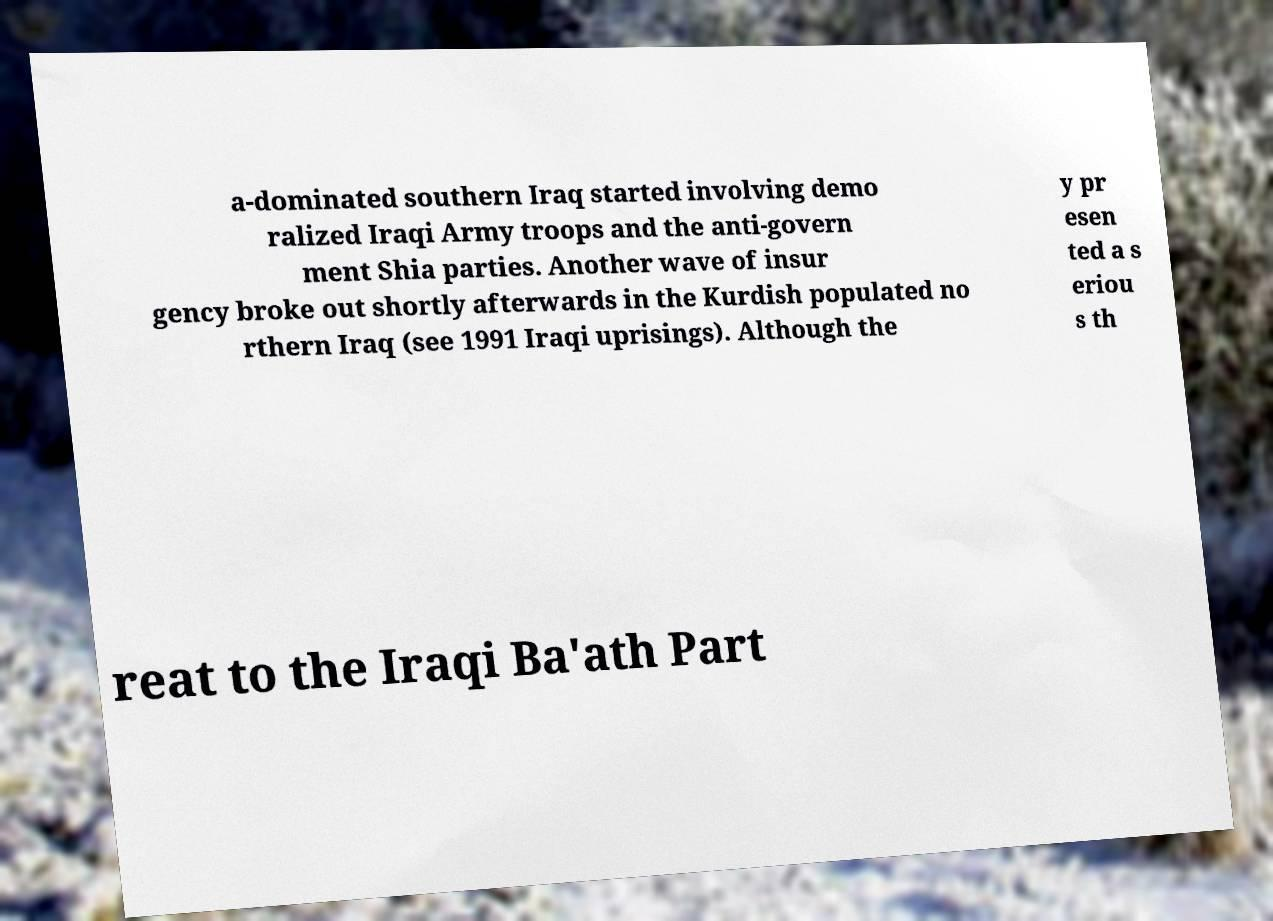Please identify and transcribe the text found in this image. a-dominated southern Iraq started involving demo ralized Iraqi Army troops and the anti-govern ment Shia parties. Another wave of insur gency broke out shortly afterwards in the Kurdish populated no rthern Iraq (see 1991 Iraqi uprisings). Although the y pr esen ted a s eriou s th reat to the Iraqi Ba'ath Part 